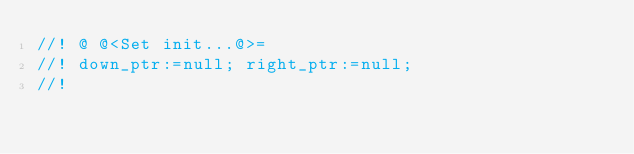<code> <loc_0><loc_0><loc_500><loc_500><_Rust_>//! @ @<Set init...@>=
//! down_ptr:=null; right_ptr:=null;
//!
</code> 